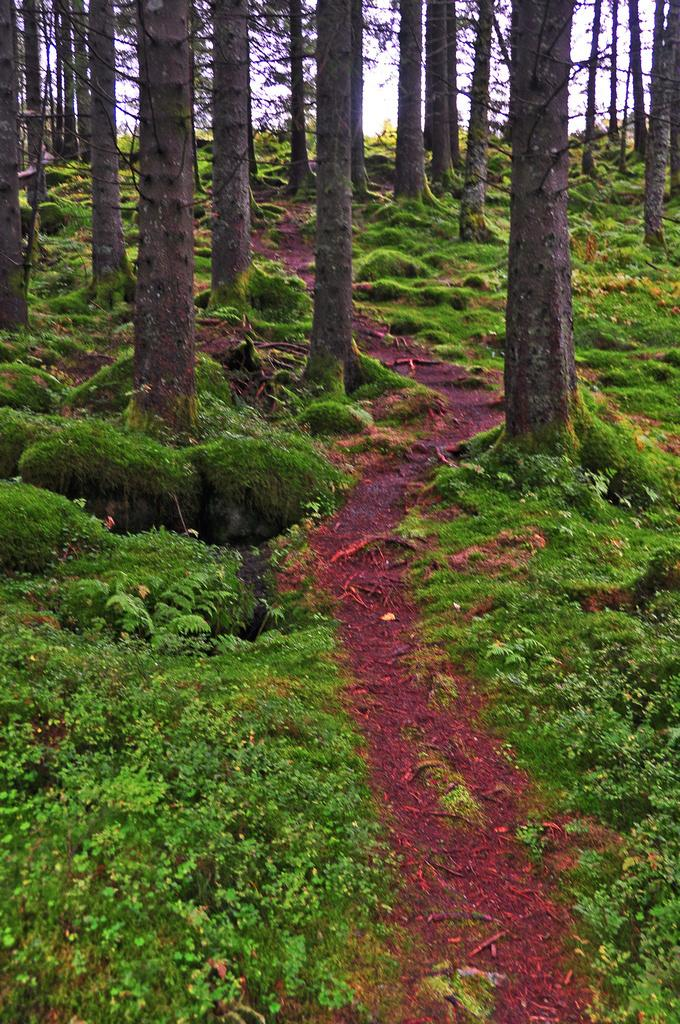What type of vegetation can be seen in the image? There are trees in the image. What is on the ground in the image? There is grass on the ground in the image. What part of the natural environment is visible in the image? The sky is visible in the background of the image. How many brothers and sisters are present in the image? There are no people, including brothers and sisters, present in the image. The image only features trees, grass, and the sky. 